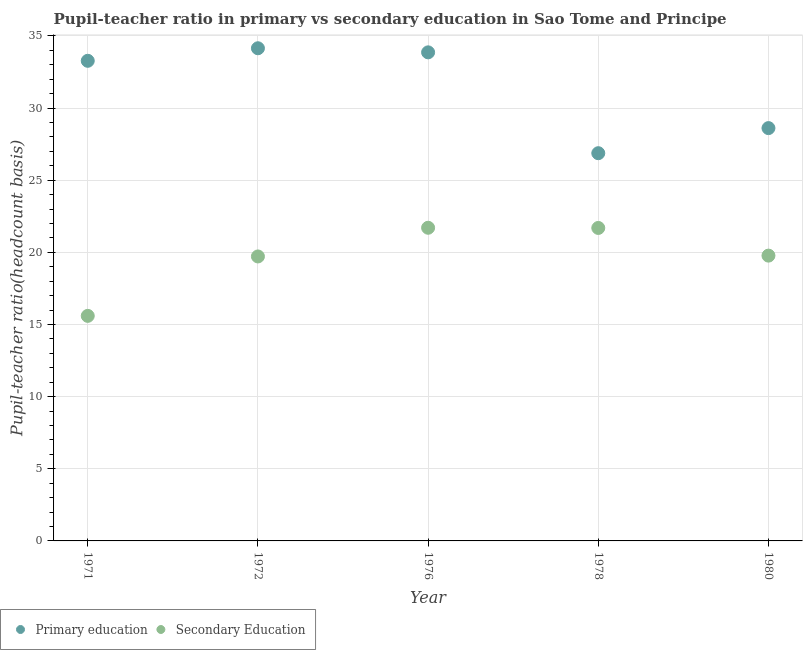How many different coloured dotlines are there?
Your response must be concise. 2. Is the number of dotlines equal to the number of legend labels?
Ensure brevity in your answer.  Yes. What is the pupil teacher ratio on secondary education in 1976?
Your answer should be very brief. 21.7. Across all years, what is the maximum pupil teacher ratio on secondary education?
Offer a very short reply. 21.7. Across all years, what is the minimum pupil teacher ratio on secondary education?
Your answer should be compact. 15.6. In which year was the pupil teacher ratio on secondary education maximum?
Ensure brevity in your answer.  1976. What is the total pupil-teacher ratio in primary education in the graph?
Provide a short and direct response. 156.77. What is the difference between the pupil-teacher ratio in primary education in 1976 and that in 1980?
Give a very brief answer. 5.25. What is the difference between the pupil-teacher ratio in primary education in 1976 and the pupil teacher ratio on secondary education in 1971?
Your answer should be very brief. 18.26. What is the average pupil teacher ratio on secondary education per year?
Offer a terse response. 19.7. In the year 1971, what is the difference between the pupil teacher ratio on secondary education and pupil-teacher ratio in primary education?
Your answer should be compact. -17.68. In how many years, is the pupil-teacher ratio in primary education greater than 5?
Make the answer very short. 5. What is the ratio of the pupil teacher ratio on secondary education in 1972 to that in 1980?
Provide a succinct answer. 1. Is the difference between the pupil teacher ratio on secondary education in 1976 and 1980 greater than the difference between the pupil-teacher ratio in primary education in 1976 and 1980?
Your answer should be very brief. No. What is the difference between the highest and the second highest pupil teacher ratio on secondary education?
Your answer should be very brief. 0.01. What is the difference between the highest and the lowest pupil-teacher ratio in primary education?
Offer a terse response. 7.27. Is the pupil teacher ratio on secondary education strictly less than the pupil-teacher ratio in primary education over the years?
Your response must be concise. Yes. Are the values on the major ticks of Y-axis written in scientific E-notation?
Make the answer very short. No. Does the graph contain any zero values?
Provide a succinct answer. No. What is the title of the graph?
Make the answer very short. Pupil-teacher ratio in primary vs secondary education in Sao Tome and Principe. What is the label or title of the X-axis?
Your response must be concise. Year. What is the label or title of the Y-axis?
Your answer should be compact. Pupil-teacher ratio(headcount basis). What is the Pupil-teacher ratio(headcount basis) in Primary education in 1971?
Your response must be concise. 33.28. What is the Pupil-teacher ratio(headcount basis) in Secondary Education in 1971?
Give a very brief answer. 15.6. What is the Pupil-teacher ratio(headcount basis) in Primary education in 1972?
Give a very brief answer. 34.15. What is the Pupil-teacher ratio(headcount basis) in Secondary Education in 1972?
Make the answer very short. 19.72. What is the Pupil-teacher ratio(headcount basis) of Primary education in 1976?
Offer a terse response. 33.86. What is the Pupil-teacher ratio(headcount basis) of Secondary Education in 1976?
Your answer should be compact. 21.7. What is the Pupil-teacher ratio(headcount basis) of Primary education in 1978?
Give a very brief answer. 26.87. What is the Pupil-teacher ratio(headcount basis) of Secondary Education in 1978?
Provide a short and direct response. 21.69. What is the Pupil-teacher ratio(headcount basis) in Primary education in 1980?
Give a very brief answer. 28.61. What is the Pupil-teacher ratio(headcount basis) of Secondary Education in 1980?
Offer a very short reply. 19.77. Across all years, what is the maximum Pupil-teacher ratio(headcount basis) of Primary education?
Offer a terse response. 34.15. Across all years, what is the maximum Pupil-teacher ratio(headcount basis) in Secondary Education?
Make the answer very short. 21.7. Across all years, what is the minimum Pupil-teacher ratio(headcount basis) of Primary education?
Keep it short and to the point. 26.87. Across all years, what is the minimum Pupil-teacher ratio(headcount basis) in Secondary Education?
Your answer should be compact. 15.6. What is the total Pupil-teacher ratio(headcount basis) of Primary education in the graph?
Your answer should be very brief. 156.77. What is the total Pupil-teacher ratio(headcount basis) of Secondary Education in the graph?
Provide a succinct answer. 98.48. What is the difference between the Pupil-teacher ratio(headcount basis) of Primary education in 1971 and that in 1972?
Provide a short and direct response. -0.87. What is the difference between the Pupil-teacher ratio(headcount basis) in Secondary Education in 1971 and that in 1972?
Ensure brevity in your answer.  -4.12. What is the difference between the Pupil-teacher ratio(headcount basis) in Primary education in 1971 and that in 1976?
Your answer should be compact. -0.59. What is the difference between the Pupil-teacher ratio(headcount basis) in Secondary Education in 1971 and that in 1976?
Keep it short and to the point. -6.11. What is the difference between the Pupil-teacher ratio(headcount basis) in Primary education in 1971 and that in 1978?
Keep it short and to the point. 6.4. What is the difference between the Pupil-teacher ratio(headcount basis) in Secondary Education in 1971 and that in 1978?
Your response must be concise. -6.09. What is the difference between the Pupil-teacher ratio(headcount basis) in Primary education in 1971 and that in 1980?
Make the answer very short. 4.67. What is the difference between the Pupil-teacher ratio(headcount basis) in Secondary Education in 1971 and that in 1980?
Ensure brevity in your answer.  -4.18. What is the difference between the Pupil-teacher ratio(headcount basis) in Primary education in 1972 and that in 1976?
Ensure brevity in your answer.  0.28. What is the difference between the Pupil-teacher ratio(headcount basis) in Secondary Education in 1972 and that in 1976?
Provide a succinct answer. -1.99. What is the difference between the Pupil-teacher ratio(headcount basis) in Primary education in 1972 and that in 1978?
Give a very brief answer. 7.27. What is the difference between the Pupil-teacher ratio(headcount basis) of Secondary Education in 1972 and that in 1978?
Offer a terse response. -1.98. What is the difference between the Pupil-teacher ratio(headcount basis) of Primary education in 1972 and that in 1980?
Offer a terse response. 5.53. What is the difference between the Pupil-teacher ratio(headcount basis) in Secondary Education in 1972 and that in 1980?
Provide a short and direct response. -0.06. What is the difference between the Pupil-teacher ratio(headcount basis) of Primary education in 1976 and that in 1978?
Your answer should be very brief. 6.99. What is the difference between the Pupil-teacher ratio(headcount basis) of Secondary Education in 1976 and that in 1978?
Offer a very short reply. 0.01. What is the difference between the Pupil-teacher ratio(headcount basis) of Primary education in 1976 and that in 1980?
Provide a succinct answer. 5.25. What is the difference between the Pupil-teacher ratio(headcount basis) of Secondary Education in 1976 and that in 1980?
Keep it short and to the point. 1.93. What is the difference between the Pupil-teacher ratio(headcount basis) in Primary education in 1978 and that in 1980?
Offer a very short reply. -1.74. What is the difference between the Pupil-teacher ratio(headcount basis) in Secondary Education in 1978 and that in 1980?
Keep it short and to the point. 1.92. What is the difference between the Pupil-teacher ratio(headcount basis) of Primary education in 1971 and the Pupil-teacher ratio(headcount basis) of Secondary Education in 1972?
Provide a short and direct response. 13.56. What is the difference between the Pupil-teacher ratio(headcount basis) of Primary education in 1971 and the Pupil-teacher ratio(headcount basis) of Secondary Education in 1976?
Ensure brevity in your answer.  11.57. What is the difference between the Pupil-teacher ratio(headcount basis) in Primary education in 1971 and the Pupil-teacher ratio(headcount basis) in Secondary Education in 1978?
Your answer should be compact. 11.59. What is the difference between the Pupil-teacher ratio(headcount basis) of Primary education in 1971 and the Pupil-teacher ratio(headcount basis) of Secondary Education in 1980?
Offer a very short reply. 13.5. What is the difference between the Pupil-teacher ratio(headcount basis) of Primary education in 1972 and the Pupil-teacher ratio(headcount basis) of Secondary Education in 1976?
Your answer should be compact. 12.44. What is the difference between the Pupil-teacher ratio(headcount basis) of Primary education in 1972 and the Pupil-teacher ratio(headcount basis) of Secondary Education in 1978?
Provide a succinct answer. 12.45. What is the difference between the Pupil-teacher ratio(headcount basis) in Primary education in 1972 and the Pupil-teacher ratio(headcount basis) in Secondary Education in 1980?
Your answer should be compact. 14.37. What is the difference between the Pupil-teacher ratio(headcount basis) of Primary education in 1976 and the Pupil-teacher ratio(headcount basis) of Secondary Education in 1978?
Provide a short and direct response. 12.17. What is the difference between the Pupil-teacher ratio(headcount basis) in Primary education in 1976 and the Pupil-teacher ratio(headcount basis) in Secondary Education in 1980?
Your answer should be compact. 14.09. What is the difference between the Pupil-teacher ratio(headcount basis) in Primary education in 1978 and the Pupil-teacher ratio(headcount basis) in Secondary Education in 1980?
Make the answer very short. 7.1. What is the average Pupil-teacher ratio(headcount basis) in Primary education per year?
Ensure brevity in your answer.  31.35. What is the average Pupil-teacher ratio(headcount basis) in Secondary Education per year?
Offer a very short reply. 19.7. In the year 1971, what is the difference between the Pupil-teacher ratio(headcount basis) in Primary education and Pupil-teacher ratio(headcount basis) in Secondary Education?
Keep it short and to the point. 17.68. In the year 1972, what is the difference between the Pupil-teacher ratio(headcount basis) of Primary education and Pupil-teacher ratio(headcount basis) of Secondary Education?
Make the answer very short. 14.43. In the year 1976, what is the difference between the Pupil-teacher ratio(headcount basis) in Primary education and Pupil-teacher ratio(headcount basis) in Secondary Education?
Keep it short and to the point. 12.16. In the year 1978, what is the difference between the Pupil-teacher ratio(headcount basis) in Primary education and Pupil-teacher ratio(headcount basis) in Secondary Education?
Offer a terse response. 5.18. In the year 1980, what is the difference between the Pupil-teacher ratio(headcount basis) of Primary education and Pupil-teacher ratio(headcount basis) of Secondary Education?
Your answer should be compact. 8.84. What is the ratio of the Pupil-teacher ratio(headcount basis) in Primary education in 1971 to that in 1972?
Your answer should be compact. 0.97. What is the ratio of the Pupil-teacher ratio(headcount basis) in Secondary Education in 1971 to that in 1972?
Your response must be concise. 0.79. What is the ratio of the Pupil-teacher ratio(headcount basis) in Primary education in 1971 to that in 1976?
Your response must be concise. 0.98. What is the ratio of the Pupil-teacher ratio(headcount basis) in Secondary Education in 1971 to that in 1976?
Your response must be concise. 0.72. What is the ratio of the Pupil-teacher ratio(headcount basis) in Primary education in 1971 to that in 1978?
Keep it short and to the point. 1.24. What is the ratio of the Pupil-teacher ratio(headcount basis) of Secondary Education in 1971 to that in 1978?
Keep it short and to the point. 0.72. What is the ratio of the Pupil-teacher ratio(headcount basis) of Primary education in 1971 to that in 1980?
Give a very brief answer. 1.16. What is the ratio of the Pupil-teacher ratio(headcount basis) in Secondary Education in 1971 to that in 1980?
Your answer should be compact. 0.79. What is the ratio of the Pupil-teacher ratio(headcount basis) in Primary education in 1972 to that in 1976?
Ensure brevity in your answer.  1.01. What is the ratio of the Pupil-teacher ratio(headcount basis) of Secondary Education in 1972 to that in 1976?
Your answer should be very brief. 0.91. What is the ratio of the Pupil-teacher ratio(headcount basis) in Primary education in 1972 to that in 1978?
Your response must be concise. 1.27. What is the ratio of the Pupil-teacher ratio(headcount basis) of Secondary Education in 1972 to that in 1978?
Make the answer very short. 0.91. What is the ratio of the Pupil-teacher ratio(headcount basis) of Primary education in 1972 to that in 1980?
Offer a terse response. 1.19. What is the ratio of the Pupil-teacher ratio(headcount basis) of Secondary Education in 1972 to that in 1980?
Make the answer very short. 1. What is the ratio of the Pupil-teacher ratio(headcount basis) in Primary education in 1976 to that in 1978?
Give a very brief answer. 1.26. What is the ratio of the Pupil-teacher ratio(headcount basis) of Primary education in 1976 to that in 1980?
Provide a succinct answer. 1.18. What is the ratio of the Pupil-teacher ratio(headcount basis) in Secondary Education in 1976 to that in 1980?
Provide a succinct answer. 1.1. What is the ratio of the Pupil-teacher ratio(headcount basis) in Primary education in 1978 to that in 1980?
Offer a very short reply. 0.94. What is the ratio of the Pupil-teacher ratio(headcount basis) in Secondary Education in 1978 to that in 1980?
Offer a terse response. 1.1. What is the difference between the highest and the second highest Pupil-teacher ratio(headcount basis) in Primary education?
Your response must be concise. 0.28. What is the difference between the highest and the second highest Pupil-teacher ratio(headcount basis) of Secondary Education?
Offer a terse response. 0.01. What is the difference between the highest and the lowest Pupil-teacher ratio(headcount basis) in Primary education?
Your answer should be very brief. 7.27. What is the difference between the highest and the lowest Pupil-teacher ratio(headcount basis) of Secondary Education?
Give a very brief answer. 6.11. 